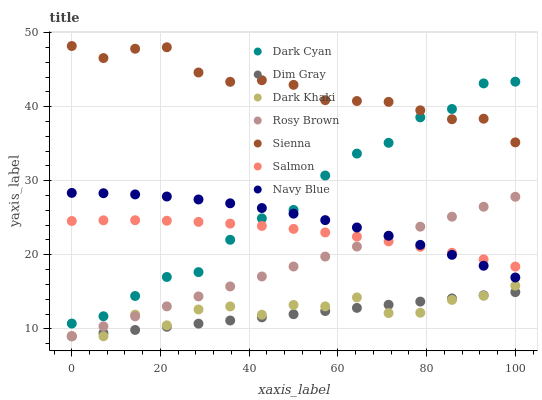Does Dim Gray have the minimum area under the curve?
Answer yes or no. Yes. Does Sienna have the maximum area under the curve?
Answer yes or no. Yes. Does Navy Blue have the minimum area under the curve?
Answer yes or no. No. Does Navy Blue have the maximum area under the curve?
Answer yes or no. No. Is Dim Gray the smoothest?
Answer yes or no. Yes. Is Dark Khaki the roughest?
Answer yes or no. Yes. Is Navy Blue the smoothest?
Answer yes or no. No. Is Navy Blue the roughest?
Answer yes or no. No. Does Dim Gray have the lowest value?
Answer yes or no. Yes. Does Navy Blue have the lowest value?
Answer yes or no. No. Does Sienna have the highest value?
Answer yes or no. Yes. Does Navy Blue have the highest value?
Answer yes or no. No. Is Rosy Brown less than Sienna?
Answer yes or no. Yes. Is Navy Blue greater than Dim Gray?
Answer yes or no. Yes. Does Dark Cyan intersect Salmon?
Answer yes or no. Yes. Is Dark Cyan less than Salmon?
Answer yes or no. No. Is Dark Cyan greater than Salmon?
Answer yes or no. No. Does Rosy Brown intersect Sienna?
Answer yes or no. No. 